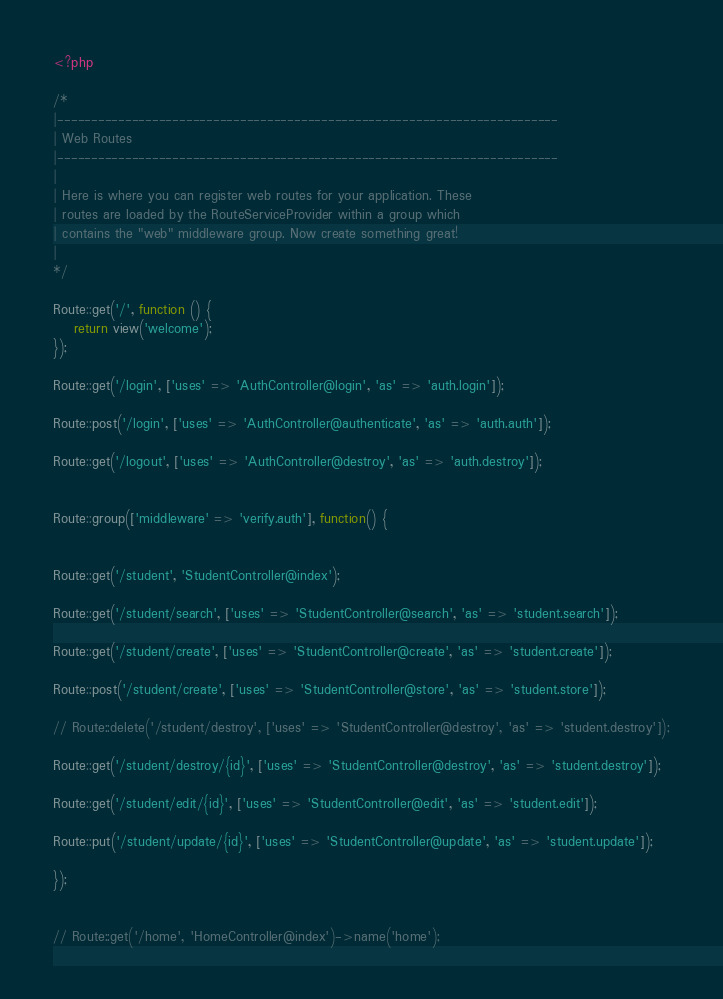<code> <loc_0><loc_0><loc_500><loc_500><_PHP_><?php

/*
|--------------------------------------------------------------------------
| Web Routes
|--------------------------------------------------------------------------
|
| Here is where you can register web routes for your application. These
| routes are loaded by the RouteServiceProvider within a group which
| contains the "web" middleware group. Now create something great!
|
*/

Route::get('/', function () {
    return view('welcome');
});

Route::get('/login', ['uses' => 'AuthController@login', 'as' => 'auth.login']);

Route::post('/login', ['uses' => 'AuthController@authenticate', 'as' => 'auth.auth']);

Route::get('/logout', ['uses' => 'AuthController@destroy', 'as' => 'auth.destroy']);


Route::group(['middleware' => 'verify.auth'], function() {


Route::get('/student', 'StudentController@index');

Route::get('/student/search', ['uses' => 'StudentController@search', 'as' => 'student.search']);

Route::get('/student/create', ['uses' => 'StudentController@create', 'as' => 'student.create']);

Route::post('/student/create', ['uses' => 'StudentController@store', 'as' => 'student.store']);

// Route::delete('/student/destroy', ['uses' => 'StudentController@destroy', 'as' => 'student.destroy']);

Route::get('/student/destroy/{id}', ['uses' => 'StudentController@destroy', 'as' => 'student.destroy']);

Route::get('/student/edit/{id}', ['uses' => 'StudentController@edit', 'as' => 'student.edit']);

Route::put('/student/update/{id}', ['uses' => 'StudentController@update', 'as' => 'student.update']);

});


// Route::get('/home', 'HomeController@index')->name('home');
</code> 